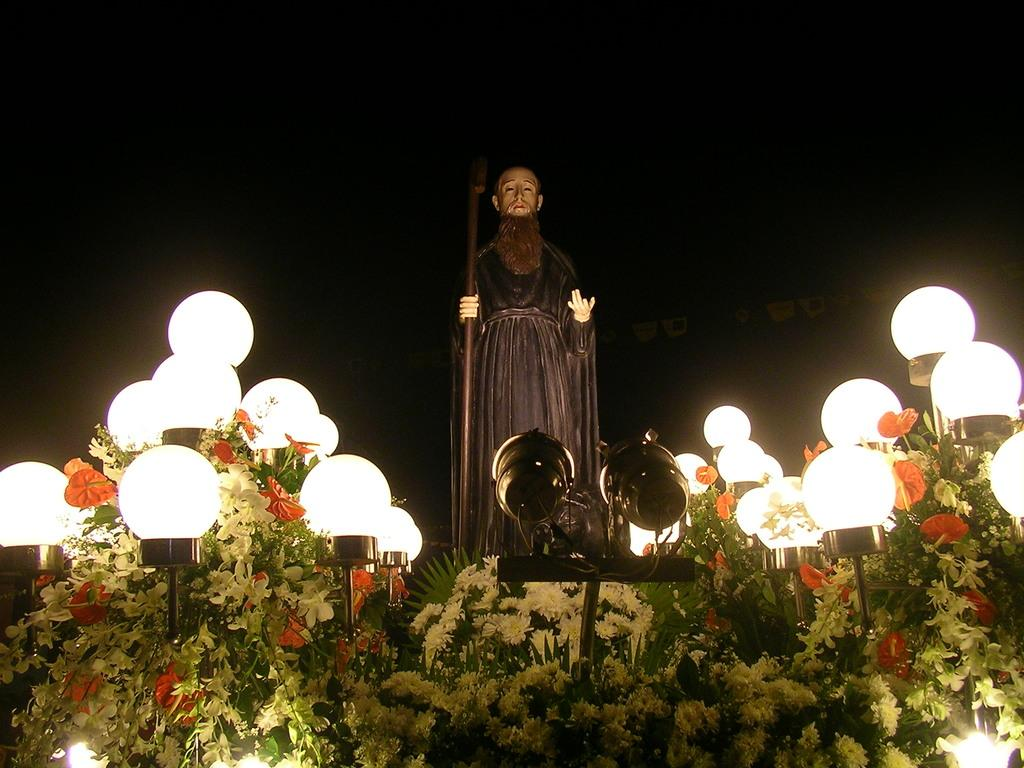What is the main subject in the center of the image? There is a statue in the center of the image. What can be seen on the right side of the image? There are lights on the right side of the image. What can be seen on the left side of the image? There are lights on the left side of the image. What is located at the bottom of the image? There are flower bouquets at the bottom of the image. What type of toy is being used to provide shade for the statue in the image? There is no toy present in the image, nor is there any indication of shade being provided for the statue. 